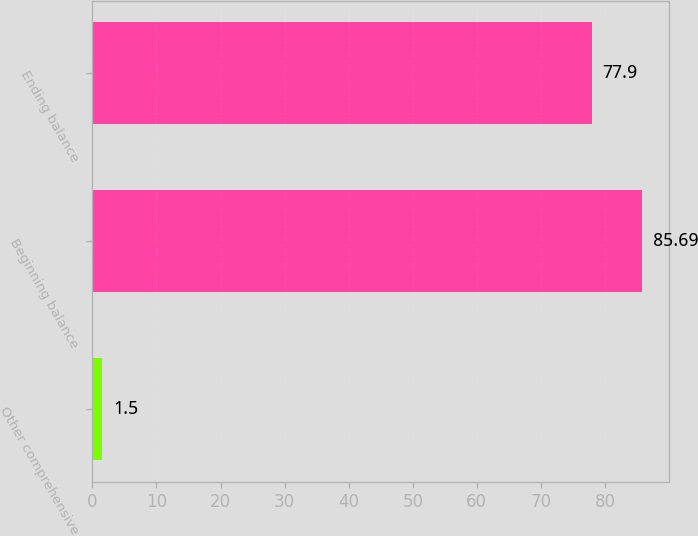Convert chart to OTSL. <chart><loc_0><loc_0><loc_500><loc_500><bar_chart><fcel>Other comprehensive<fcel>Beginning balance<fcel>Ending balance<nl><fcel>1.5<fcel>85.69<fcel>77.9<nl></chart> 